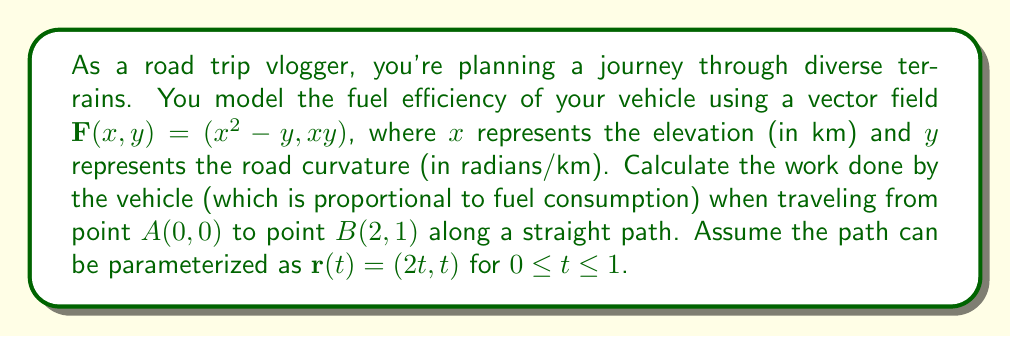Teach me how to tackle this problem. To solve this problem, we'll use the line integral of a vector field along a curve. The work done is given by the line integral of $\mathbf{F}$ along the path from $A$ to $B$.

1) First, we need to express the vector field $\mathbf{F}$ in terms of the parameter $t$:
   $\mathbf{F}(\mathbf{r}(t)) = ((2t)^2 - t, (2t)(t)) = (4t^2 - t, 2t^2)$

2) Next, we calculate $\frac{d\mathbf{r}}{dt}$:
   $\frac{d\mathbf{r}}{dt} = (2, 1)$

3) The line integral is given by:
   $$W = \int_C \mathbf{F} \cdot d\mathbf{r} = \int_0^1 \mathbf{F}(\mathbf{r}(t)) \cdot \frac{d\mathbf{r}}{dt} dt$$

4) Substitute the expressions we found in steps 1 and 2:
   $$W = \int_0^1 [(4t^2 - t, 2t^2) \cdot (2, 1)] dt$$

5) Compute the dot product:
   $$W = \int_0^1 [(4t^2 - t)(2) + (2t^2)(1)] dt = \int_0^1 (8t^2 - 2t + 2t^2) dt = \int_0^1 (10t^2 - 2t) dt$$

6) Integrate:
   $$W = [\frac{10t^3}{3} - t^2]_0^1 = (\frac{10}{3} - 1) - (0 - 0) = \frac{7}{3}$$

Therefore, the work done by the vehicle (proportional to fuel consumption) is $\frac{7}{3}$ units.
Answer: $\frac{7}{3}$ units of work 